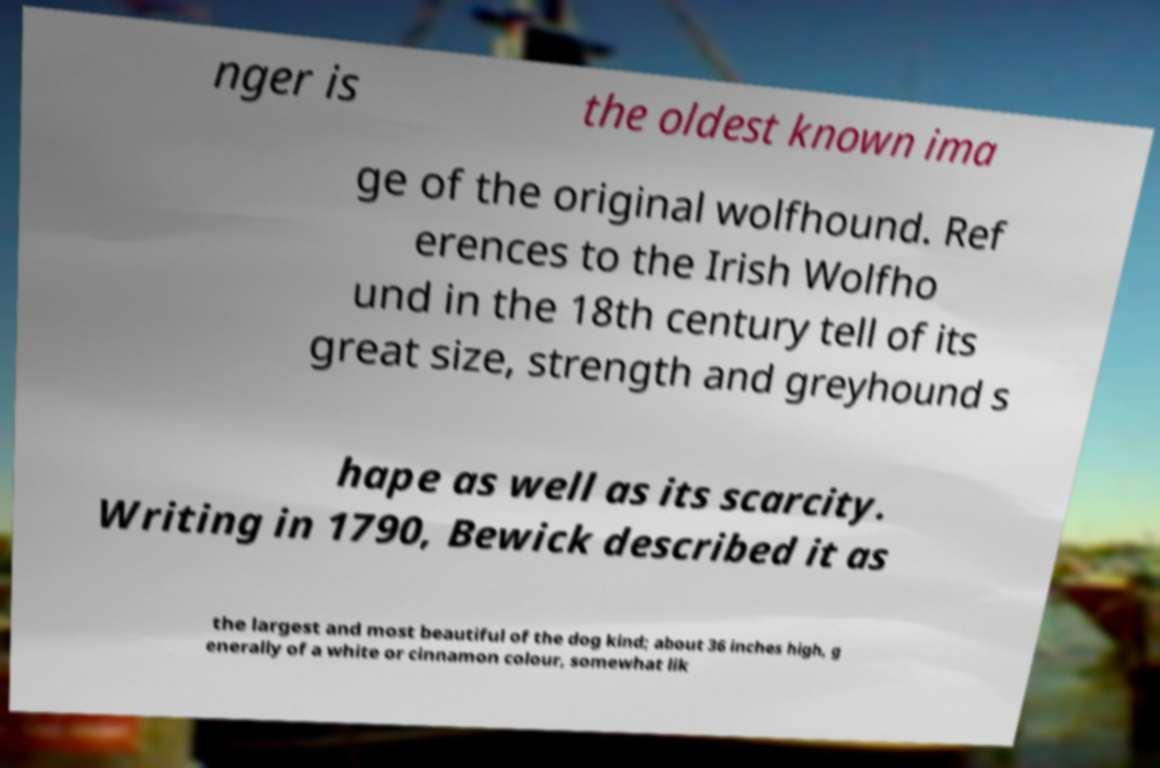Can you read and provide the text displayed in the image?This photo seems to have some interesting text. Can you extract and type it out for me? nger is the oldest known ima ge of the original wolfhound. Ref erences to the Irish Wolfho und in the 18th century tell of its great size, strength and greyhound s hape as well as its scarcity. Writing in 1790, Bewick described it as the largest and most beautiful of the dog kind; about 36 inches high, g enerally of a white or cinnamon colour, somewhat lik 